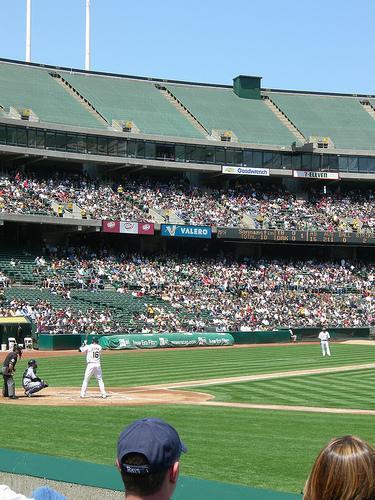How many umpires are in the photo?
Give a very brief answer. 1. 